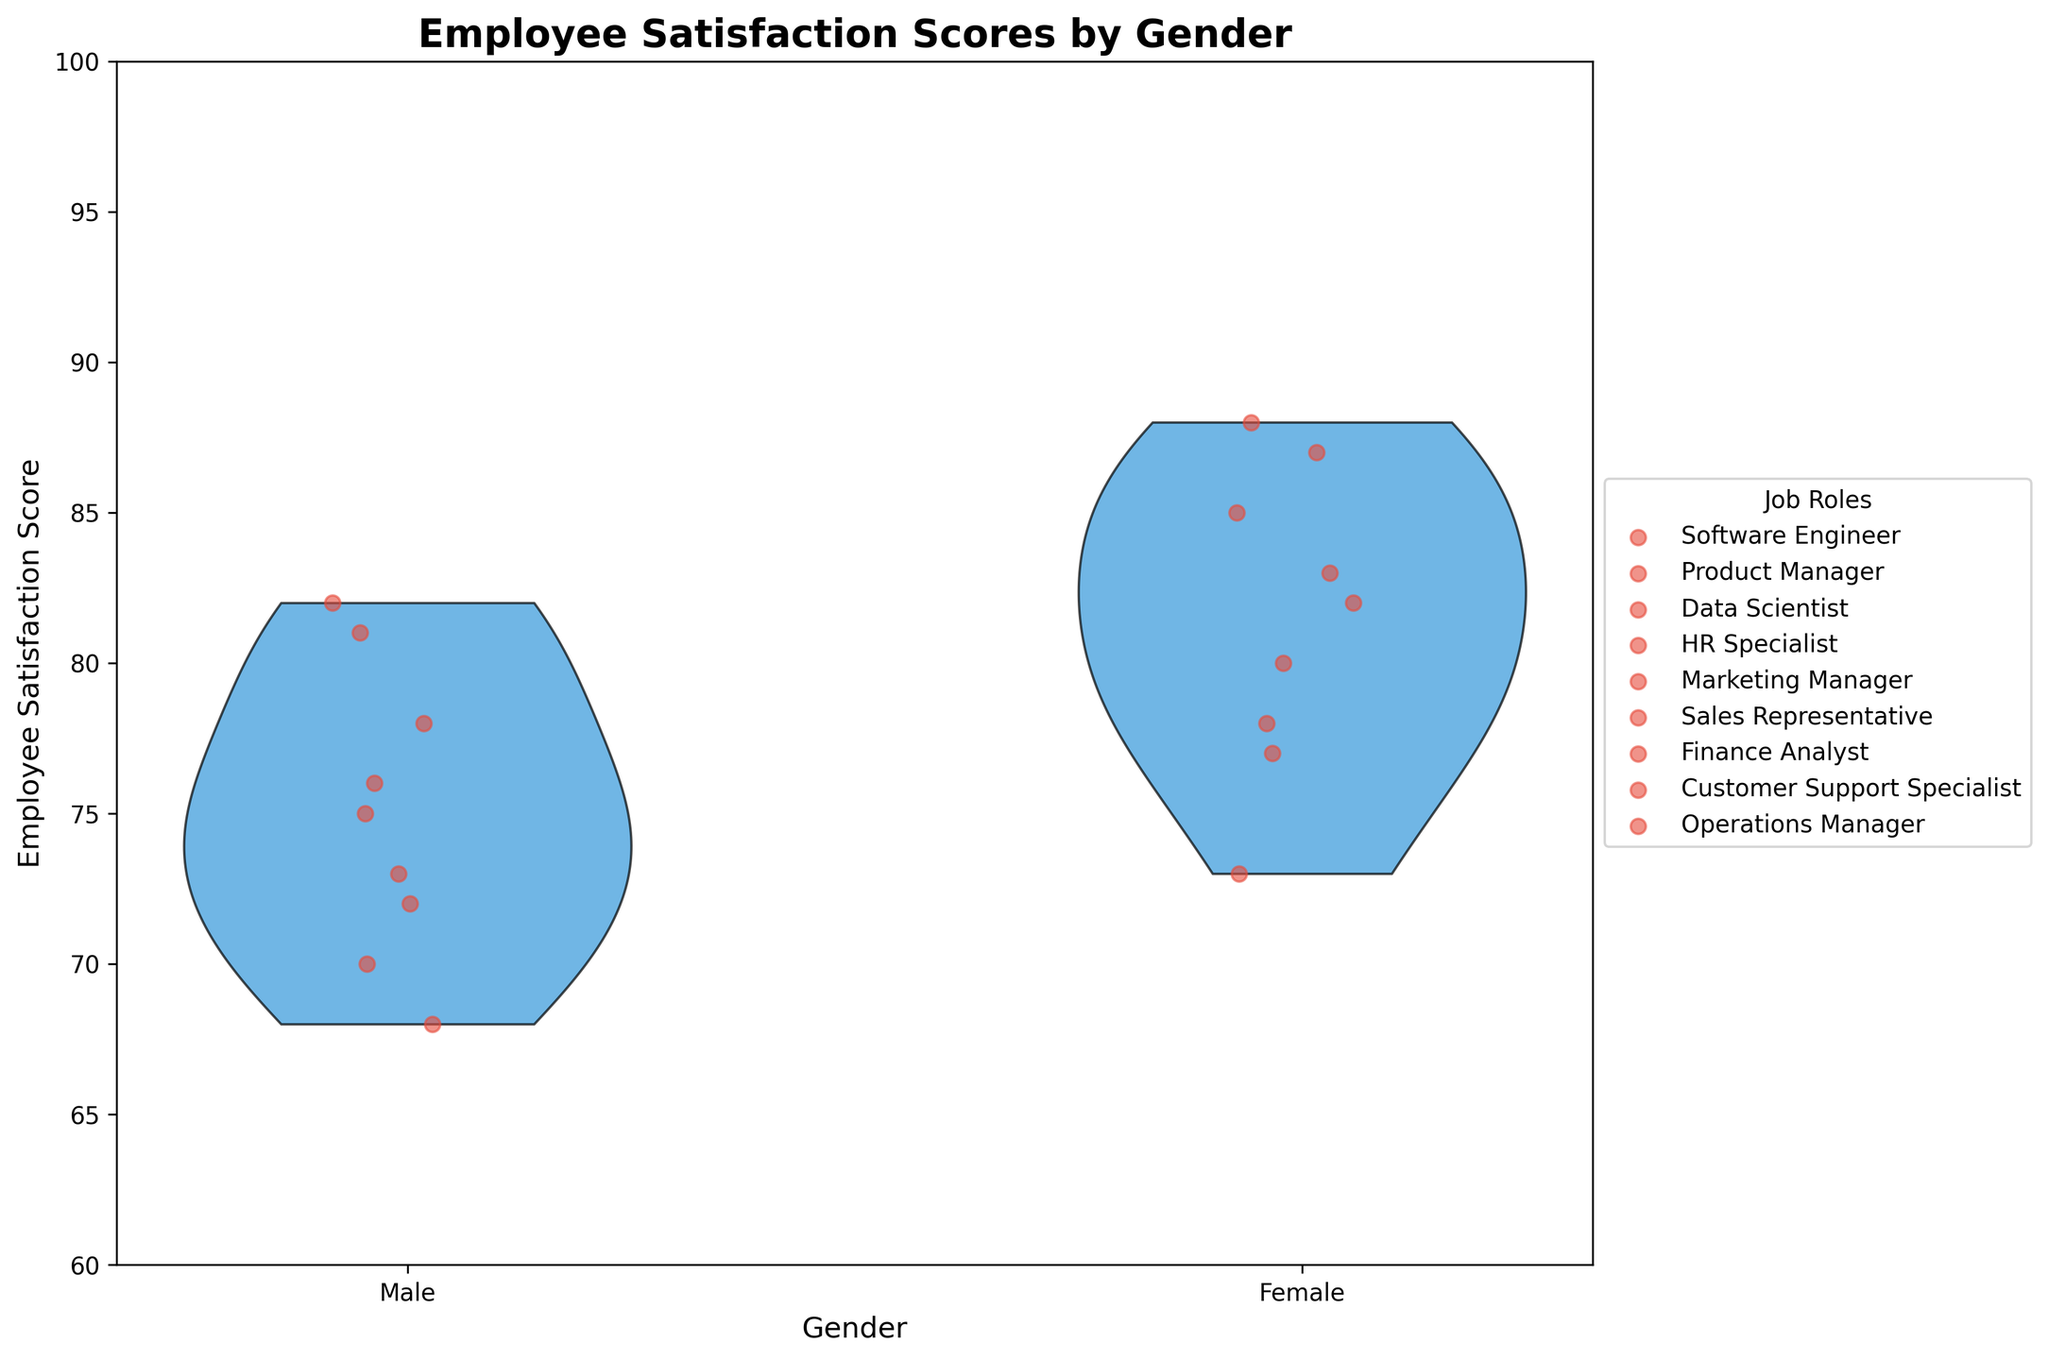What is the title of the figure? The title of the figure is displayed at the top of the plot and summarizes the main subject. It reads "Employee Satisfaction Scores by Gender".
Answer: Employee Satisfaction Scores by Gender How many unique job roles are shown in the figure? The legend on the right side of the plot lists all the unique job roles categorized by different scatter plot points. By counting these labels, we identify 10 unique job roles.
Answer: 10 Which gender has a higher average employee satisfaction score across all job roles? By observing the violin plot and the scatter points, it is apparent that the female group’s portion of the violin is generally positioned higher compared to the male group, indicating higher satisfaction scores.
Answer: Female What is the range of employee satisfaction scores shown in the figure? The y-axis of the figure shows the range of satisfaction scores, starting at 60 and going up to 100. This is the complete range displayed in the plot.
Answer: 60 to 100 Which job role shows the largest difference in employee satisfaction scores between genders? By examining the scatter plot points within each role, the largest vertical gap between male and female satisfaction scores occurs for Data Scientists. Male satisfaction score is 82 while female is 88, resulting in the largest difference of 6 points.
Answer: Data Scientist What’s the employee satisfaction score for Male Product Managers? Look at the scatter plot points for the Male category and find the point that corresponds to Product Managers. The score is marked at 73.
Answer: 73 Compare the median employee satisfaction scores for males and females. After visually estimating the center points of the violin splits for each gender, the female median appears higher compared to the male median. The exact numerical median is not provided, but the graphical median line in the female section consistently appears at higher values.
Answer: Female median is higher How does the dispersion of employee satisfaction scores differ between genders? This can be interpreted by looking at the width and shape of each violin plot. The female plot seems to be more spread out, indicating more variability in satisfaction scores compared to the male plot which appears more compact.
Answer: Female scores are more spread out Which gender has the lowest employee satisfaction score and in which job role? By identifying the lowest point across the scatter plots, the lowest score is 68 for a male Sales Representative.
Answer: Male Sales Representative What’s the difference in employee satisfaction score between Male and Female Finance Analysts? Find the scatter plot points for Finance Analysts under both Male and Female categories. Male score is 81 and Female score is 87. The difference is 87 - 81 = 6.
Answer: 6 